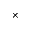Convert formula to latex. <formula><loc_0><loc_0><loc_500><loc_500>\times</formula> 